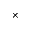Convert formula to latex. <formula><loc_0><loc_0><loc_500><loc_500>\times</formula> 